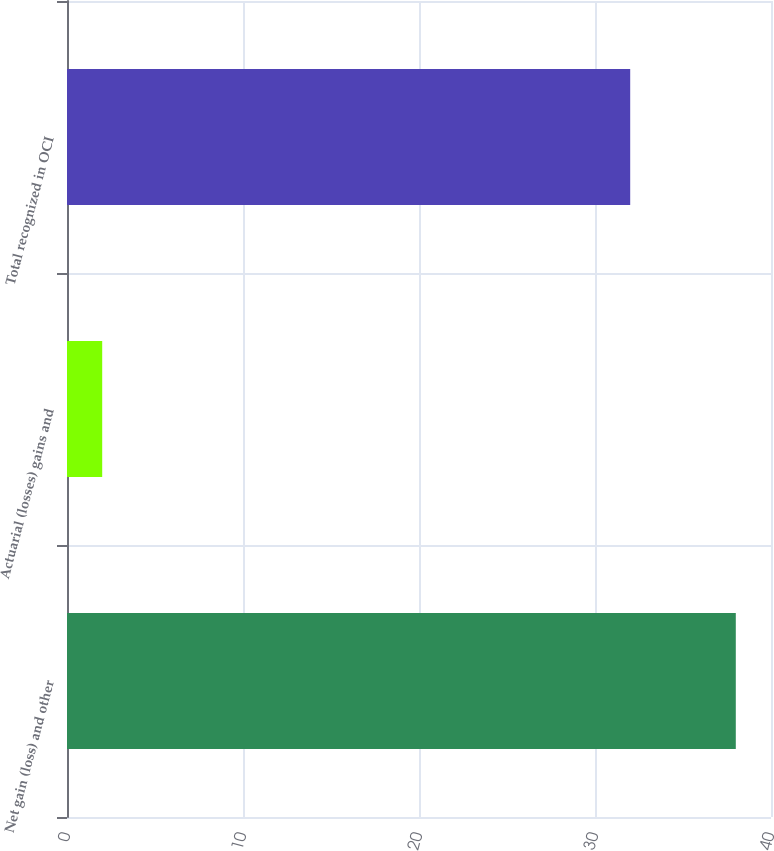<chart> <loc_0><loc_0><loc_500><loc_500><bar_chart><fcel>Net gain (loss) and other<fcel>Actuarial (losses) gains and<fcel>Total recognized in OCI<nl><fcel>38<fcel>2<fcel>32<nl></chart> 